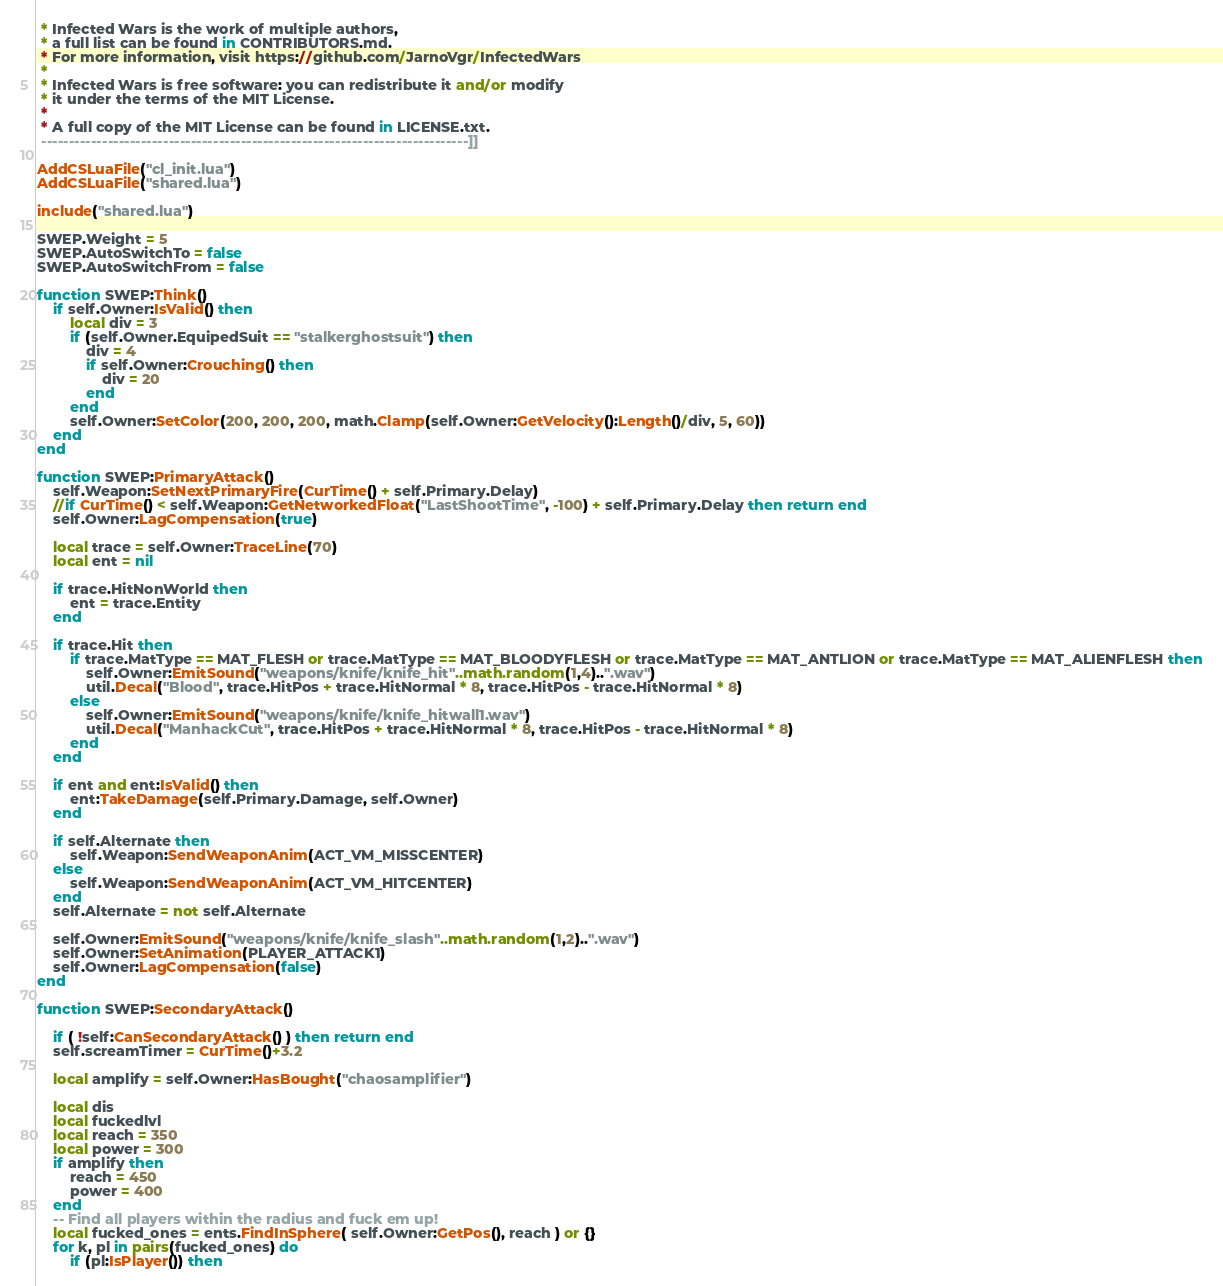<code> <loc_0><loc_0><loc_500><loc_500><_Lua_> * Infected Wars is the work of multiple authors,
 * a full list can be found in CONTRIBUTORS.md.
 * For more information, visit https://github.com/JarnoVgr/InfectedWars
 *
 * Infected Wars is free software: you can redistribute it and/or modify
 * it under the terms of the MIT License.
 *
 * A full copy of the MIT License can be found in LICENSE.txt.
 -----------------------------------------------------------------------------]]

AddCSLuaFile("cl_init.lua")
AddCSLuaFile("shared.lua")

include("shared.lua")

SWEP.Weight = 5
SWEP.AutoSwitchTo = false
SWEP.AutoSwitchFrom = false

function SWEP:Think()
	if self.Owner:IsValid() then
		local div = 3
		if (self.Owner.EquipedSuit == "stalkerghostsuit") then
			div = 4
			if self.Owner:Crouching() then
				div = 20
			end
		end
		self.Owner:SetColor(200, 200, 200, math.Clamp(self.Owner:GetVelocity():Length()/div, 5, 60))
	end
end

function SWEP:PrimaryAttack()
	self.Weapon:SetNextPrimaryFire(CurTime() + self.Primary.Delay)
	//if CurTime() < self.Weapon:GetNetworkedFloat("LastShootTime", -100) + self.Primary.Delay then return end
	self.Owner:LagCompensation(true)

	local trace = self.Owner:TraceLine(70)
	local ent = nil

	if trace.HitNonWorld then
		ent = trace.Entity
	end

	if trace.Hit then
		if trace.MatType == MAT_FLESH or trace.MatType == MAT_BLOODYFLESH or trace.MatType == MAT_ANTLION or trace.MatType == MAT_ALIENFLESH then
			self.Owner:EmitSound("weapons/knife/knife_hit"..math.random(1,4)..".wav")
			util.Decal("Blood", trace.HitPos + trace.HitNormal * 8, trace.HitPos - trace.HitNormal * 8)
		else
			self.Owner:EmitSound("weapons/knife/knife_hitwall1.wav")
			util.Decal("ManhackCut", trace.HitPos + trace.HitNormal * 8, trace.HitPos - trace.HitNormal * 8)
		end
	end

	if ent and ent:IsValid() then
	    ent:TakeDamage(self.Primary.Damage, self.Owner)
	end

	if self.Alternate then
		self.Weapon:SendWeaponAnim(ACT_VM_MISSCENTER)
	else
		self.Weapon:SendWeaponAnim(ACT_VM_HITCENTER)
	end
	self.Alternate = not self.Alternate

	self.Owner:EmitSound("weapons/knife/knife_slash"..math.random(1,2)..".wav")
	self.Owner:SetAnimation(PLAYER_ATTACK1)
	self.Owner:LagCompensation(false)
end

function SWEP:SecondaryAttack()
	
	if ( !self:CanSecondaryAttack() ) then return end
	self.screamTimer = CurTime()+3.2
	
	local amplify = self.Owner:HasBought("chaosamplifier")
	
	local dis
	local fuckedlvl
	local reach = 350
	local power = 300
	if amplify then
		reach = 450
		power = 400
	end
	-- Find all players within the radius and fuck em up!
	local fucked_ones = ents.FindInSphere( self.Owner:GetPos(), reach ) or {}
	for k, pl in pairs(fucked_ones) do
		if (pl:IsPlayer()) then</code> 